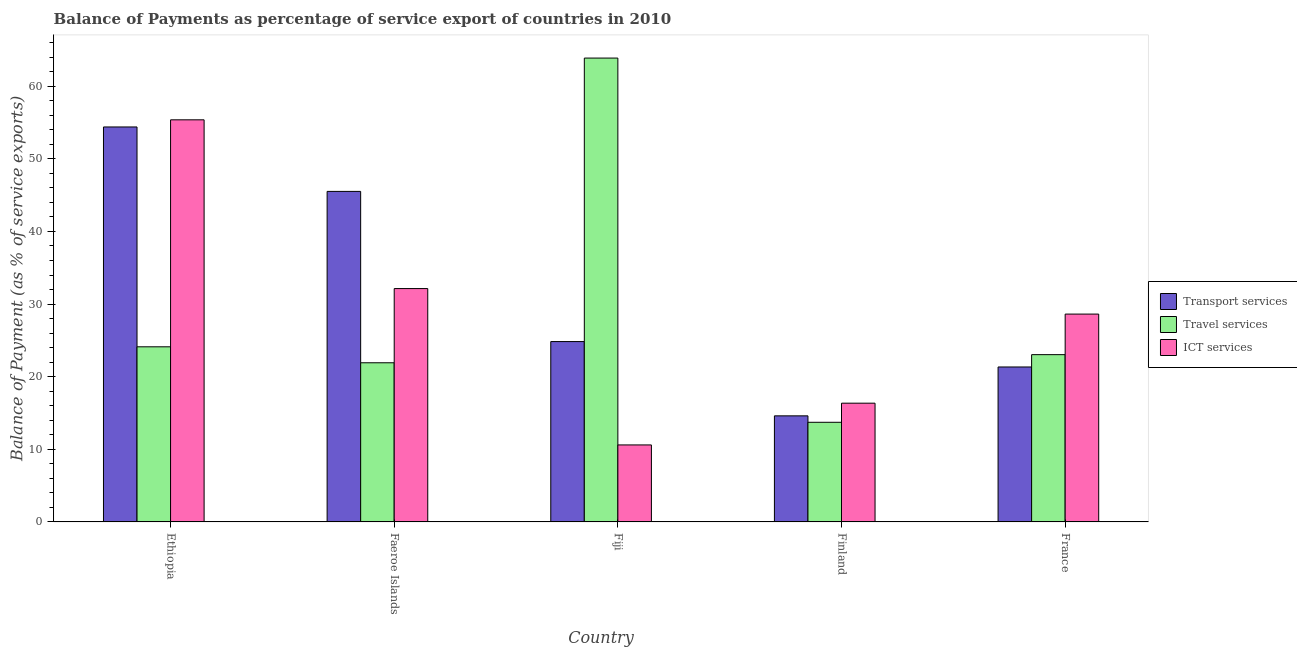How many different coloured bars are there?
Make the answer very short. 3. How many groups of bars are there?
Provide a short and direct response. 5. Are the number of bars per tick equal to the number of legend labels?
Your response must be concise. Yes. Are the number of bars on each tick of the X-axis equal?
Provide a succinct answer. Yes. How many bars are there on the 1st tick from the right?
Ensure brevity in your answer.  3. What is the label of the 3rd group of bars from the left?
Offer a very short reply. Fiji. What is the balance of payment of ict services in Fiji?
Provide a short and direct response. 10.6. Across all countries, what is the maximum balance of payment of travel services?
Your answer should be compact. 63.88. Across all countries, what is the minimum balance of payment of transport services?
Make the answer very short. 14.61. In which country was the balance of payment of travel services maximum?
Your answer should be compact. Fiji. In which country was the balance of payment of travel services minimum?
Your answer should be very brief. Finland. What is the total balance of payment of travel services in the graph?
Provide a succinct answer. 146.67. What is the difference between the balance of payment of ict services in Ethiopia and that in France?
Keep it short and to the point. 26.75. What is the difference between the balance of payment of ict services in Fiji and the balance of payment of transport services in Faeroe Islands?
Your answer should be very brief. -34.92. What is the average balance of payment of transport services per country?
Your answer should be very brief. 32.14. What is the difference between the balance of payment of ict services and balance of payment of travel services in Fiji?
Ensure brevity in your answer.  -53.28. In how many countries, is the balance of payment of transport services greater than 38 %?
Offer a terse response. 2. What is the ratio of the balance of payment of transport services in Ethiopia to that in France?
Your response must be concise. 2.55. Is the difference between the balance of payment of ict services in Fiji and Finland greater than the difference between the balance of payment of travel services in Fiji and Finland?
Offer a very short reply. No. What is the difference between the highest and the second highest balance of payment of ict services?
Your response must be concise. 23.24. What is the difference between the highest and the lowest balance of payment of ict services?
Offer a very short reply. 44.77. What does the 3rd bar from the left in Finland represents?
Your response must be concise. ICT services. What does the 1st bar from the right in Finland represents?
Offer a terse response. ICT services. Are all the bars in the graph horizontal?
Your answer should be very brief. No. What is the difference between two consecutive major ticks on the Y-axis?
Ensure brevity in your answer.  10. Does the graph contain any zero values?
Your answer should be very brief. No. Where does the legend appear in the graph?
Give a very brief answer. Center right. How many legend labels are there?
Provide a short and direct response. 3. What is the title of the graph?
Offer a terse response. Balance of Payments as percentage of service export of countries in 2010. What is the label or title of the X-axis?
Your response must be concise. Country. What is the label or title of the Y-axis?
Offer a very short reply. Balance of Payment (as % of service exports). What is the Balance of Payment (as % of service exports) of Transport services in Ethiopia?
Ensure brevity in your answer.  54.39. What is the Balance of Payment (as % of service exports) in Travel services in Ethiopia?
Offer a terse response. 24.12. What is the Balance of Payment (as % of service exports) of ICT services in Ethiopia?
Your response must be concise. 55.38. What is the Balance of Payment (as % of service exports) in Transport services in Faeroe Islands?
Your response must be concise. 45.52. What is the Balance of Payment (as % of service exports) in Travel services in Faeroe Islands?
Give a very brief answer. 21.92. What is the Balance of Payment (as % of service exports) of ICT services in Faeroe Islands?
Your answer should be compact. 32.14. What is the Balance of Payment (as % of service exports) in Transport services in Fiji?
Your answer should be compact. 24.84. What is the Balance of Payment (as % of service exports) in Travel services in Fiji?
Ensure brevity in your answer.  63.88. What is the Balance of Payment (as % of service exports) in ICT services in Fiji?
Make the answer very short. 10.6. What is the Balance of Payment (as % of service exports) of Transport services in Finland?
Offer a terse response. 14.61. What is the Balance of Payment (as % of service exports) in Travel services in Finland?
Your response must be concise. 13.72. What is the Balance of Payment (as % of service exports) of ICT services in Finland?
Provide a succinct answer. 16.35. What is the Balance of Payment (as % of service exports) in Transport services in France?
Offer a very short reply. 21.34. What is the Balance of Payment (as % of service exports) of Travel services in France?
Keep it short and to the point. 23.04. What is the Balance of Payment (as % of service exports) of ICT services in France?
Offer a very short reply. 28.62. Across all countries, what is the maximum Balance of Payment (as % of service exports) in Transport services?
Provide a succinct answer. 54.39. Across all countries, what is the maximum Balance of Payment (as % of service exports) in Travel services?
Make the answer very short. 63.88. Across all countries, what is the maximum Balance of Payment (as % of service exports) of ICT services?
Give a very brief answer. 55.38. Across all countries, what is the minimum Balance of Payment (as % of service exports) in Transport services?
Your answer should be compact. 14.61. Across all countries, what is the minimum Balance of Payment (as % of service exports) of Travel services?
Your answer should be very brief. 13.72. Across all countries, what is the minimum Balance of Payment (as % of service exports) in ICT services?
Offer a very short reply. 10.6. What is the total Balance of Payment (as % of service exports) of Transport services in the graph?
Your answer should be very brief. 160.7. What is the total Balance of Payment (as % of service exports) of Travel services in the graph?
Offer a very short reply. 146.67. What is the total Balance of Payment (as % of service exports) of ICT services in the graph?
Your response must be concise. 143.09. What is the difference between the Balance of Payment (as % of service exports) in Transport services in Ethiopia and that in Faeroe Islands?
Your answer should be very brief. 8.87. What is the difference between the Balance of Payment (as % of service exports) of Travel services in Ethiopia and that in Faeroe Islands?
Give a very brief answer. 2.2. What is the difference between the Balance of Payment (as % of service exports) of ICT services in Ethiopia and that in Faeroe Islands?
Offer a very short reply. 23.24. What is the difference between the Balance of Payment (as % of service exports) of Transport services in Ethiopia and that in Fiji?
Keep it short and to the point. 29.56. What is the difference between the Balance of Payment (as % of service exports) of Travel services in Ethiopia and that in Fiji?
Provide a succinct answer. -39.77. What is the difference between the Balance of Payment (as % of service exports) of ICT services in Ethiopia and that in Fiji?
Give a very brief answer. 44.77. What is the difference between the Balance of Payment (as % of service exports) in Transport services in Ethiopia and that in Finland?
Give a very brief answer. 39.78. What is the difference between the Balance of Payment (as % of service exports) in Travel services in Ethiopia and that in Finland?
Provide a succinct answer. 10.4. What is the difference between the Balance of Payment (as % of service exports) of ICT services in Ethiopia and that in Finland?
Offer a terse response. 39.02. What is the difference between the Balance of Payment (as % of service exports) in Transport services in Ethiopia and that in France?
Ensure brevity in your answer.  33.05. What is the difference between the Balance of Payment (as % of service exports) in Travel services in Ethiopia and that in France?
Your answer should be compact. 1.08. What is the difference between the Balance of Payment (as % of service exports) in ICT services in Ethiopia and that in France?
Provide a short and direct response. 26.75. What is the difference between the Balance of Payment (as % of service exports) in Transport services in Faeroe Islands and that in Fiji?
Your response must be concise. 20.68. What is the difference between the Balance of Payment (as % of service exports) of Travel services in Faeroe Islands and that in Fiji?
Keep it short and to the point. -41.96. What is the difference between the Balance of Payment (as % of service exports) in ICT services in Faeroe Islands and that in Fiji?
Ensure brevity in your answer.  21.54. What is the difference between the Balance of Payment (as % of service exports) in Transport services in Faeroe Islands and that in Finland?
Give a very brief answer. 30.91. What is the difference between the Balance of Payment (as % of service exports) of Travel services in Faeroe Islands and that in Finland?
Offer a terse response. 8.2. What is the difference between the Balance of Payment (as % of service exports) of ICT services in Faeroe Islands and that in Finland?
Ensure brevity in your answer.  15.78. What is the difference between the Balance of Payment (as % of service exports) in Transport services in Faeroe Islands and that in France?
Make the answer very short. 24.18. What is the difference between the Balance of Payment (as % of service exports) of Travel services in Faeroe Islands and that in France?
Give a very brief answer. -1.12. What is the difference between the Balance of Payment (as % of service exports) of ICT services in Faeroe Islands and that in France?
Offer a very short reply. 3.51. What is the difference between the Balance of Payment (as % of service exports) of Transport services in Fiji and that in Finland?
Your response must be concise. 10.23. What is the difference between the Balance of Payment (as % of service exports) of Travel services in Fiji and that in Finland?
Ensure brevity in your answer.  50.16. What is the difference between the Balance of Payment (as % of service exports) in ICT services in Fiji and that in Finland?
Provide a short and direct response. -5.75. What is the difference between the Balance of Payment (as % of service exports) in Transport services in Fiji and that in France?
Make the answer very short. 3.5. What is the difference between the Balance of Payment (as % of service exports) in Travel services in Fiji and that in France?
Provide a short and direct response. 40.84. What is the difference between the Balance of Payment (as % of service exports) in ICT services in Fiji and that in France?
Offer a very short reply. -18.02. What is the difference between the Balance of Payment (as % of service exports) of Transport services in Finland and that in France?
Make the answer very short. -6.73. What is the difference between the Balance of Payment (as % of service exports) of Travel services in Finland and that in France?
Keep it short and to the point. -9.32. What is the difference between the Balance of Payment (as % of service exports) in ICT services in Finland and that in France?
Ensure brevity in your answer.  -12.27. What is the difference between the Balance of Payment (as % of service exports) of Transport services in Ethiopia and the Balance of Payment (as % of service exports) of Travel services in Faeroe Islands?
Offer a terse response. 32.48. What is the difference between the Balance of Payment (as % of service exports) of Transport services in Ethiopia and the Balance of Payment (as % of service exports) of ICT services in Faeroe Islands?
Give a very brief answer. 22.26. What is the difference between the Balance of Payment (as % of service exports) in Travel services in Ethiopia and the Balance of Payment (as % of service exports) in ICT services in Faeroe Islands?
Provide a short and direct response. -8.02. What is the difference between the Balance of Payment (as % of service exports) of Transport services in Ethiopia and the Balance of Payment (as % of service exports) of Travel services in Fiji?
Give a very brief answer. -9.49. What is the difference between the Balance of Payment (as % of service exports) in Transport services in Ethiopia and the Balance of Payment (as % of service exports) in ICT services in Fiji?
Provide a short and direct response. 43.79. What is the difference between the Balance of Payment (as % of service exports) of Travel services in Ethiopia and the Balance of Payment (as % of service exports) of ICT services in Fiji?
Offer a very short reply. 13.51. What is the difference between the Balance of Payment (as % of service exports) of Transport services in Ethiopia and the Balance of Payment (as % of service exports) of Travel services in Finland?
Give a very brief answer. 40.67. What is the difference between the Balance of Payment (as % of service exports) in Transport services in Ethiopia and the Balance of Payment (as % of service exports) in ICT services in Finland?
Keep it short and to the point. 38.04. What is the difference between the Balance of Payment (as % of service exports) in Travel services in Ethiopia and the Balance of Payment (as % of service exports) in ICT services in Finland?
Keep it short and to the point. 7.76. What is the difference between the Balance of Payment (as % of service exports) in Transport services in Ethiopia and the Balance of Payment (as % of service exports) in Travel services in France?
Your response must be concise. 31.36. What is the difference between the Balance of Payment (as % of service exports) in Transport services in Ethiopia and the Balance of Payment (as % of service exports) in ICT services in France?
Keep it short and to the point. 25.77. What is the difference between the Balance of Payment (as % of service exports) of Travel services in Ethiopia and the Balance of Payment (as % of service exports) of ICT services in France?
Ensure brevity in your answer.  -4.51. What is the difference between the Balance of Payment (as % of service exports) in Transport services in Faeroe Islands and the Balance of Payment (as % of service exports) in Travel services in Fiji?
Your response must be concise. -18.36. What is the difference between the Balance of Payment (as % of service exports) of Transport services in Faeroe Islands and the Balance of Payment (as % of service exports) of ICT services in Fiji?
Make the answer very short. 34.92. What is the difference between the Balance of Payment (as % of service exports) of Travel services in Faeroe Islands and the Balance of Payment (as % of service exports) of ICT services in Fiji?
Your answer should be very brief. 11.31. What is the difference between the Balance of Payment (as % of service exports) in Transport services in Faeroe Islands and the Balance of Payment (as % of service exports) in Travel services in Finland?
Your answer should be compact. 31.8. What is the difference between the Balance of Payment (as % of service exports) of Transport services in Faeroe Islands and the Balance of Payment (as % of service exports) of ICT services in Finland?
Ensure brevity in your answer.  29.17. What is the difference between the Balance of Payment (as % of service exports) of Travel services in Faeroe Islands and the Balance of Payment (as % of service exports) of ICT services in Finland?
Offer a terse response. 5.56. What is the difference between the Balance of Payment (as % of service exports) in Transport services in Faeroe Islands and the Balance of Payment (as % of service exports) in Travel services in France?
Offer a terse response. 22.48. What is the difference between the Balance of Payment (as % of service exports) in Transport services in Faeroe Islands and the Balance of Payment (as % of service exports) in ICT services in France?
Provide a short and direct response. 16.9. What is the difference between the Balance of Payment (as % of service exports) in Travel services in Faeroe Islands and the Balance of Payment (as % of service exports) in ICT services in France?
Your answer should be very brief. -6.71. What is the difference between the Balance of Payment (as % of service exports) of Transport services in Fiji and the Balance of Payment (as % of service exports) of Travel services in Finland?
Offer a very short reply. 11.12. What is the difference between the Balance of Payment (as % of service exports) of Transport services in Fiji and the Balance of Payment (as % of service exports) of ICT services in Finland?
Give a very brief answer. 8.48. What is the difference between the Balance of Payment (as % of service exports) in Travel services in Fiji and the Balance of Payment (as % of service exports) in ICT services in Finland?
Offer a very short reply. 47.53. What is the difference between the Balance of Payment (as % of service exports) in Transport services in Fiji and the Balance of Payment (as % of service exports) in Travel services in France?
Your answer should be very brief. 1.8. What is the difference between the Balance of Payment (as % of service exports) in Transport services in Fiji and the Balance of Payment (as % of service exports) in ICT services in France?
Ensure brevity in your answer.  -3.79. What is the difference between the Balance of Payment (as % of service exports) in Travel services in Fiji and the Balance of Payment (as % of service exports) in ICT services in France?
Provide a succinct answer. 35.26. What is the difference between the Balance of Payment (as % of service exports) in Transport services in Finland and the Balance of Payment (as % of service exports) in Travel services in France?
Offer a very short reply. -8.43. What is the difference between the Balance of Payment (as % of service exports) in Transport services in Finland and the Balance of Payment (as % of service exports) in ICT services in France?
Keep it short and to the point. -14.02. What is the difference between the Balance of Payment (as % of service exports) in Travel services in Finland and the Balance of Payment (as % of service exports) in ICT services in France?
Make the answer very short. -14.9. What is the average Balance of Payment (as % of service exports) of Transport services per country?
Offer a terse response. 32.14. What is the average Balance of Payment (as % of service exports) of Travel services per country?
Ensure brevity in your answer.  29.33. What is the average Balance of Payment (as % of service exports) of ICT services per country?
Your answer should be compact. 28.62. What is the difference between the Balance of Payment (as % of service exports) in Transport services and Balance of Payment (as % of service exports) in Travel services in Ethiopia?
Offer a very short reply. 30.28. What is the difference between the Balance of Payment (as % of service exports) in Transport services and Balance of Payment (as % of service exports) in ICT services in Ethiopia?
Your answer should be compact. -0.98. What is the difference between the Balance of Payment (as % of service exports) in Travel services and Balance of Payment (as % of service exports) in ICT services in Ethiopia?
Provide a succinct answer. -31.26. What is the difference between the Balance of Payment (as % of service exports) in Transport services and Balance of Payment (as % of service exports) in Travel services in Faeroe Islands?
Offer a terse response. 23.6. What is the difference between the Balance of Payment (as % of service exports) of Transport services and Balance of Payment (as % of service exports) of ICT services in Faeroe Islands?
Your answer should be very brief. 13.38. What is the difference between the Balance of Payment (as % of service exports) of Travel services and Balance of Payment (as % of service exports) of ICT services in Faeroe Islands?
Your response must be concise. -10.22. What is the difference between the Balance of Payment (as % of service exports) of Transport services and Balance of Payment (as % of service exports) of Travel services in Fiji?
Keep it short and to the point. -39.04. What is the difference between the Balance of Payment (as % of service exports) in Transport services and Balance of Payment (as % of service exports) in ICT services in Fiji?
Your answer should be compact. 14.23. What is the difference between the Balance of Payment (as % of service exports) in Travel services and Balance of Payment (as % of service exports) in ICT services in Fiji?
Your response must be concise. 53.28. What is the difference between the Balance of Payment (as % of service exports) of Transport services and Balance of Payment (as % of service exports) of Travel services in Finland?
Give a very brief answer. 0.89. What is the difference between the Balance of Payment (as % of service exports) in Transport services and Balance of Payment (as % of service exports) in ICT services in Finland?
Your answer should be very brief. -1.74. What is the difference between the Balance of Payment (as % of service exports) in Travel services and Balance of Payment (as % of service exports) in ICT services in Finland?
Your answer should be compact. -2.63. What is the difference between the Balance of Payment (as % of service exports) of Transport services and Balance of Payment (as % of service exports) of Travel services in France?
Offer a very short reply. -1.7. What is the difference between the Balance of Payment (as % of service exports) of Transport services and Balance of Payment (as % of service exports) of ICT services in France?
Provide a succinct answer. -7.28. What is the difference between the Balance of Payment (as % of service exports) in Travel services and Balance of Payment (as % of service exports) in ICT services in France?
Provide a succinct answer. -5.59. What is the ratio of the Balance of Payment (as % of service exports) of Transport services in Ethiopia to that in Faeroe Islands?
Your response must be concise. 1.2. What is the ratio of the Balance of Payment (as % of service exports) in Travel services in Ethiopia to that in Faeroe Islands?
Keep it short and to the point. 1.1. What is the ratio of the Balance of Payment (as % of service exports) in ICT services in Ethiopia to that in Faeroe Islands?
Offer a terse response. 1.72. What is the ratio of the Balance of Payment (as % of service exports) of Transport services in Ethiopia to that in Fiji?
Give a very brief answer. 2.19. What is the ratio of the Balance of Payment (as % of service exports) of Travel services in Ethiopia to that in Fiji?
Your answer should be very brief. 0.38. What is the ratio of the Balance of Payment (as % of service exports) in ICT services in Ethiopia to that in Fiji?
Your answer should be very brief. 5.22. What is the ratio of the Balance of Payment (as % of service exports) in Transport services in Ethiopia to that in Finland?
Your answer should be compact. 3.72. What is the ratio of the Balance of Payment (as % of service exports) in Travel services in Ethiopia to that in Finland?
Offer a very short reply. 1.76. What is the ratio of the Balance of Payment (as % of service exports) of ICT services in Ethiopia to that in Finland?
Provide a short and direct response. 3.39. What is the ratio of the Balance of Payment (as % of service exports) of Transport services in Ethiopia to that in France?
Provide a short and direct response. 2.55. What is the ratio of the Balance of Payment (as % of service exports) of Travel services in Ethiopia to that in France?
Give a very brief answer. 1.05. What is the ratio of the Balance of Payment (as % of service exports) of ICT services in Ethiopia to that in France?
Provide a succinct answer. 1.93. What is the ratio of the Balance of Payment (as % of service exports) in Transport services in Faeroe Islands to that in Fiji?
Ensure brevity in your answer.  1.83. What is the ratio of the Balance of Payment (as % of service exports) of Travel services in Faeroe Islands to that in Fiji?
Give a very brief answer. 0.34. What is the ratio of the Balance of Payment (as % of service exports) in ICT services in Faeroe Islands to that in Fiji?
Keep it short and to the point. 3.03. What is the ratio of the Balance of Payment (as % of service exports) in Transport services in Faeroe Islands to that in Finland?
Your answer should be very brief. 3.12. What is the ratio of the Balance of Payment (as % of service exports) in Travel services in Faeroe Islands to that in Finland?
Provide a succinct answer. 1.6. What is the ratio of the Balance of Payment (as % of service exports) in ICT services in Faeroe Islands to that in Finland?
Your answer should be very brief. 1.97. What is the ratio of the Balance of Payment (as % of service exports) in Transport services in Faeroe Islands to that in France?
Your answer should be compact. 2.13. What is the ratio of the Balance of Payment (as % of service exports) in Travel services in Faeroe Islands to that in France?
Make the answer very short. 0.95. What is the ratio of the Balance of Payment (as % of service exports) of ICT services in Faeroe Islands to that in France?
Offer a very short reply. 1.12. What is the ratio of the Balance of Payment (as % of service exports) of Transport services in Fiji to that in Finland?
Ensure brevity in your answer.  1.7. What is the ratio of the Balance of Payment (as % of service exports) in Travel services in Fiji to that in Finland?
Offer a very short reply. 4.66. What is the ratio of the Balance of Payment (as % of service exports) in ICT services in Fiji to that in Finland?
Keep it short and to the point. 0.65. What is the ratio of the Balance of Payment (as % of service exports) in Transport services in Fiji to that in France?
Give a very brief answer. 1.16. What is the ratio of the Balance of Payment (as % of service exports) in Travel services in Fiji to that in France?
Your answer should be compact. 2.77. What is the ratio of the Balance of Payment (as % of service exports) in ICT services in Fiji to that in France?
Your response must be concise. 0.37. What is the ratio of the Balance of Payment (as % of service exports) in Transport services in Finland to that in France?
Your answer should be compact. 0.68. What is the ratio of the Balance of Payment (as % of service exports) in Travel services in Finland to that in France?
Your answer should be compact. 0.6. What is the ratio of the Balance of Payment (as % of service exports) of ICT services in Finland to that in France?
Your answer should be compact. 0.57. What is the difference between the highest and the second highest Balance of Payment (as % of service exports) in Transport services?
Make the answer very short. 8.87. What is the difference between the highest and the second highest Balance of Payment (as % of service exports) of Travel services?
Your answer should be compact. 39.77. What is the difference between the highest and the second highest Balance of Payment (as % of service exports) in ICT services?
Your answer should be compact. 23.24. What is the difference between the highest and the lowest Balance of Payment (as % of service exports) in Transport services?
Your answer should be compact. 39.78. What is the difference between the highest and the lowest Balance of Payment (as % of service exports) in Travel services?
Give a very brief answer. 50.16. What is the difference between the highest and the lowest Balance of Payment (as % of service exports) in ICT services?
Give a very brief answer. 44.77. 